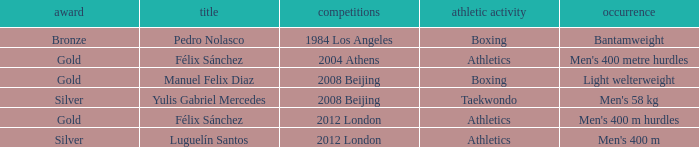Which Medal had a Name of félix sánchez, and a Games of 2012 london? Gold. 